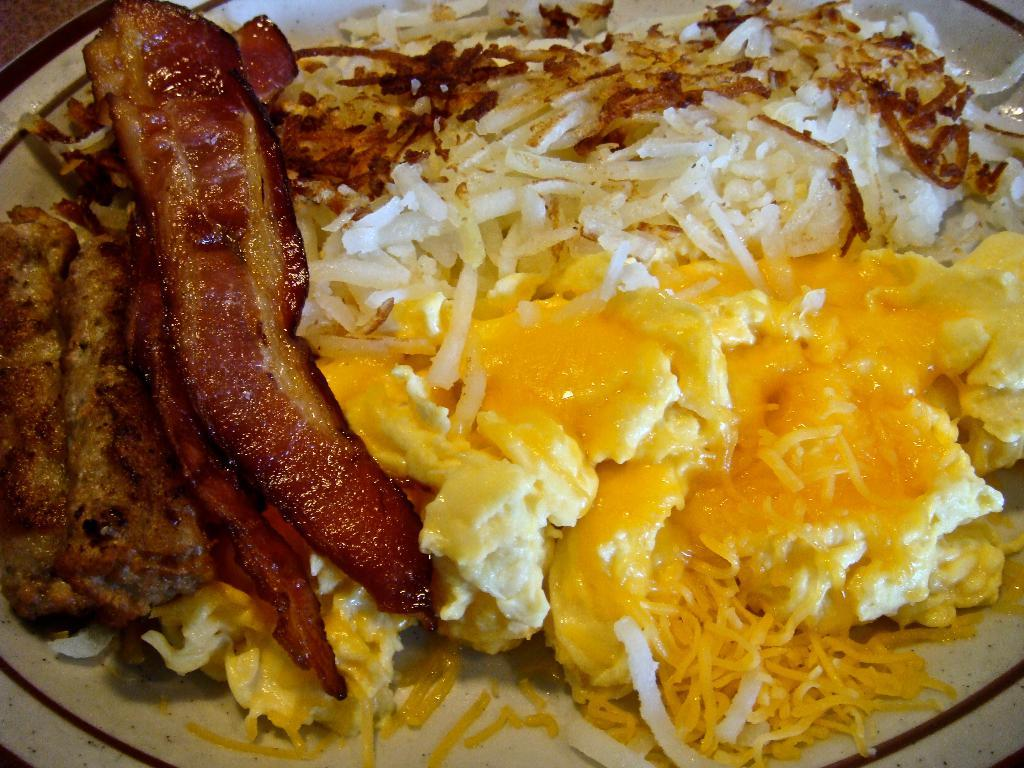What is the main subject of the image? The main subject of the image is a plate. What can be found on the plate? The plate contains food items. What type of instrument is being played by the neck in the image? There is no neck or instrument present in the image; it is a close-up or zoomed in view of a plate containing food items. 